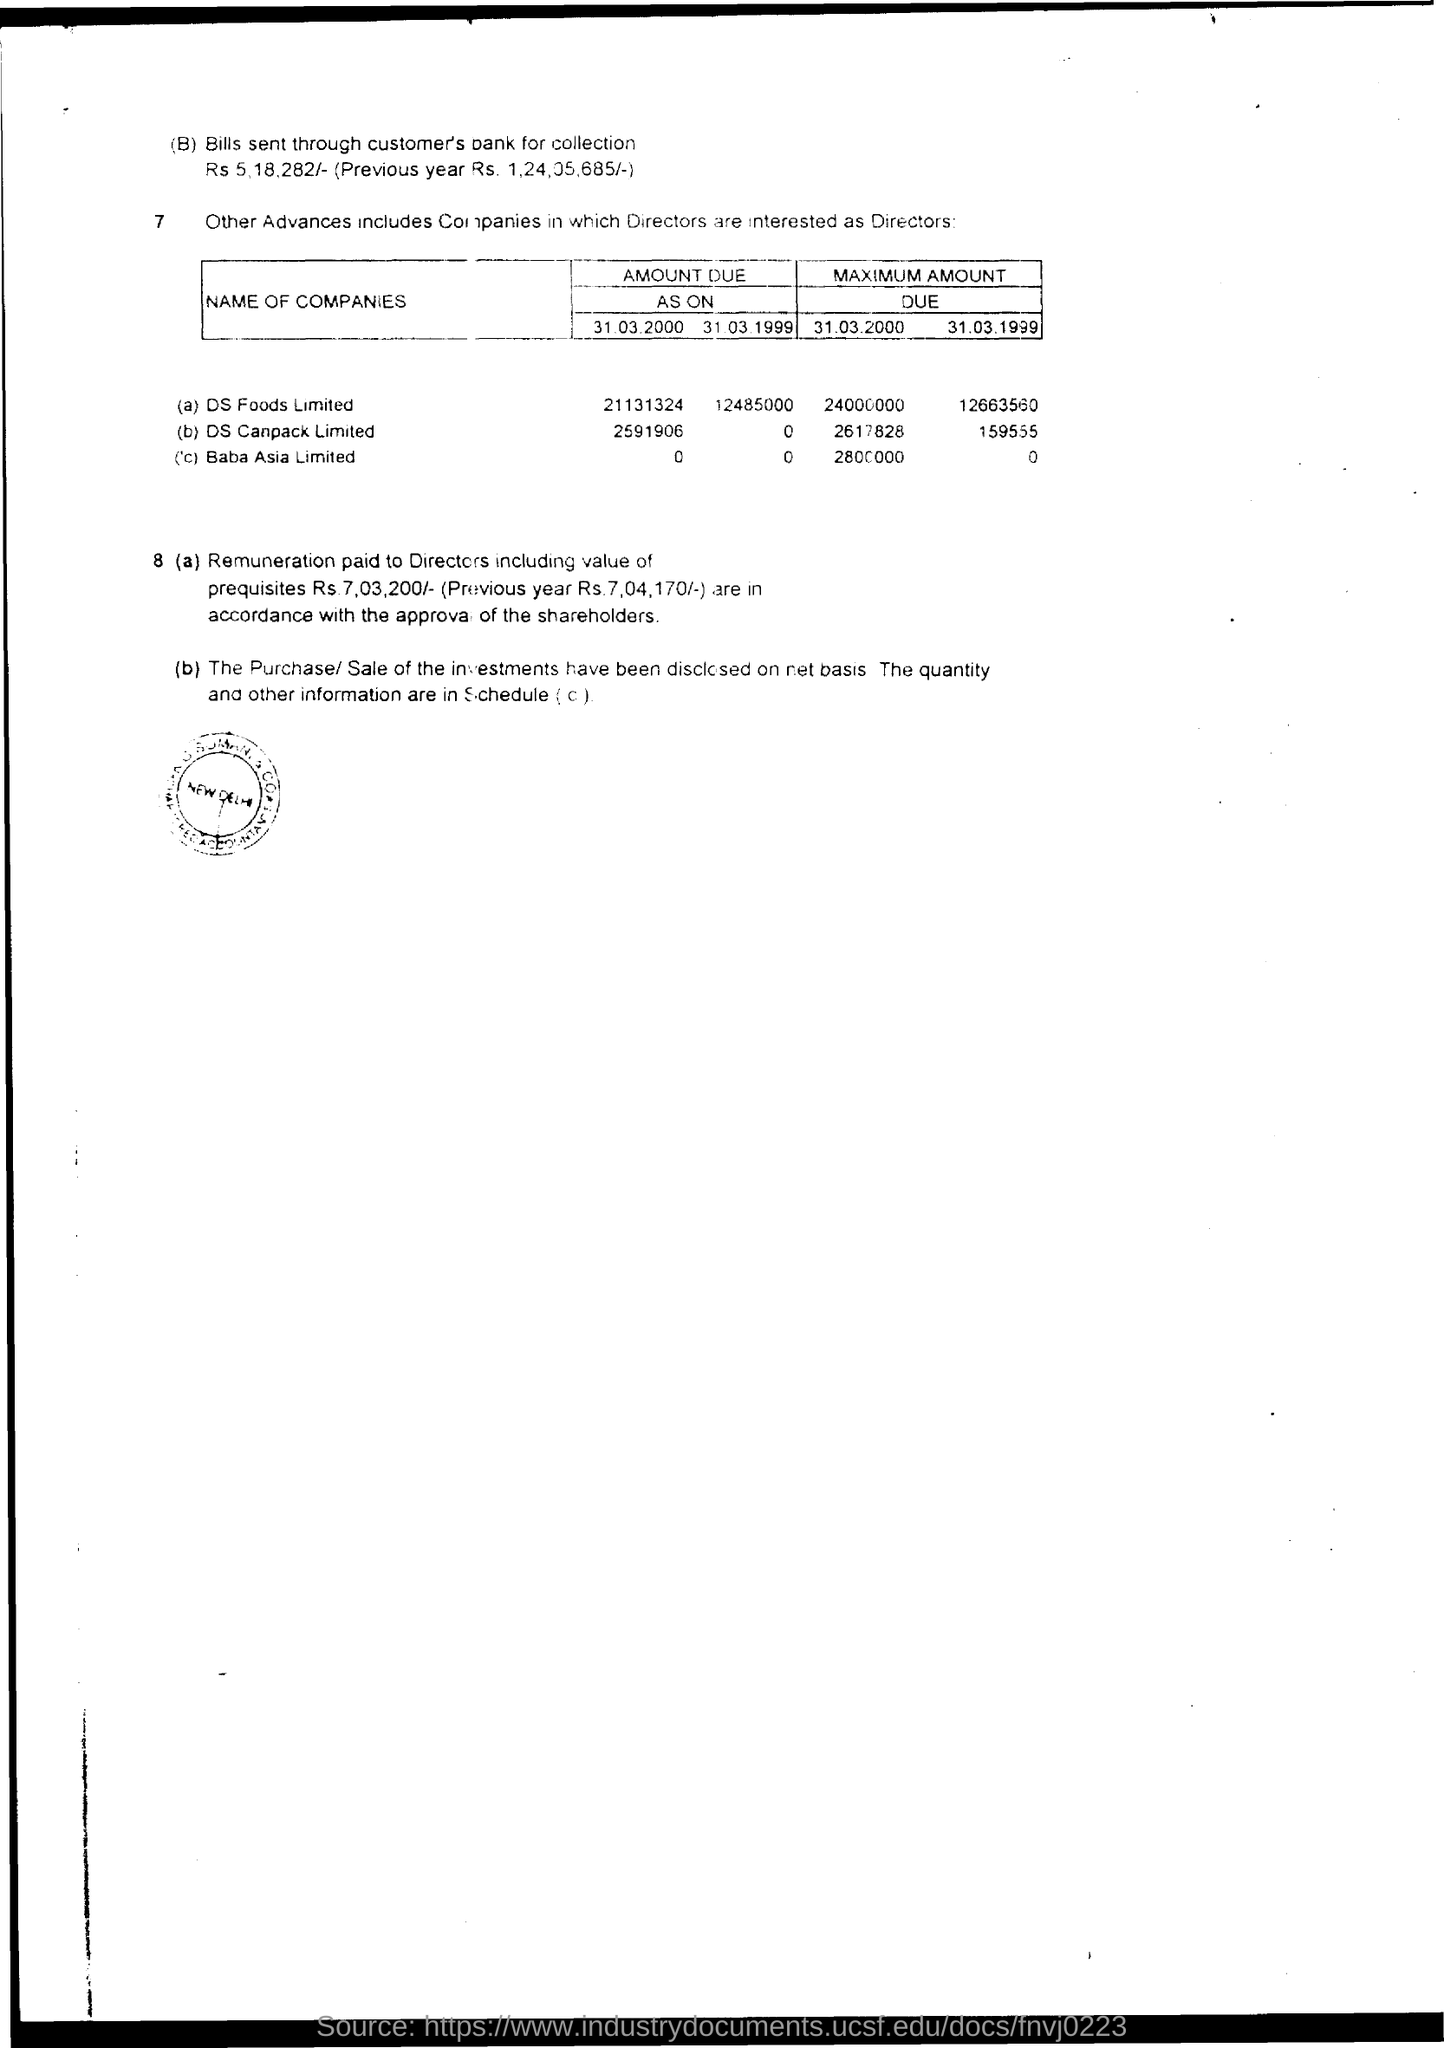Identify some key points in this picture. On March 31, 2000, the maximum amount due for Baba Asia Limited is 2800000. The bill amount sent for collection through the customer's bank is Rs. 5,18,282/-. The remuneration paid to Directors, including the value of perquisites, was Rs 7,03,200/-. As on March 31, 1999, the amount due for DS Foods Limited was 12,485,000. What is the maximum amount due on March 31, 1999 for DS Canpack Limited? 